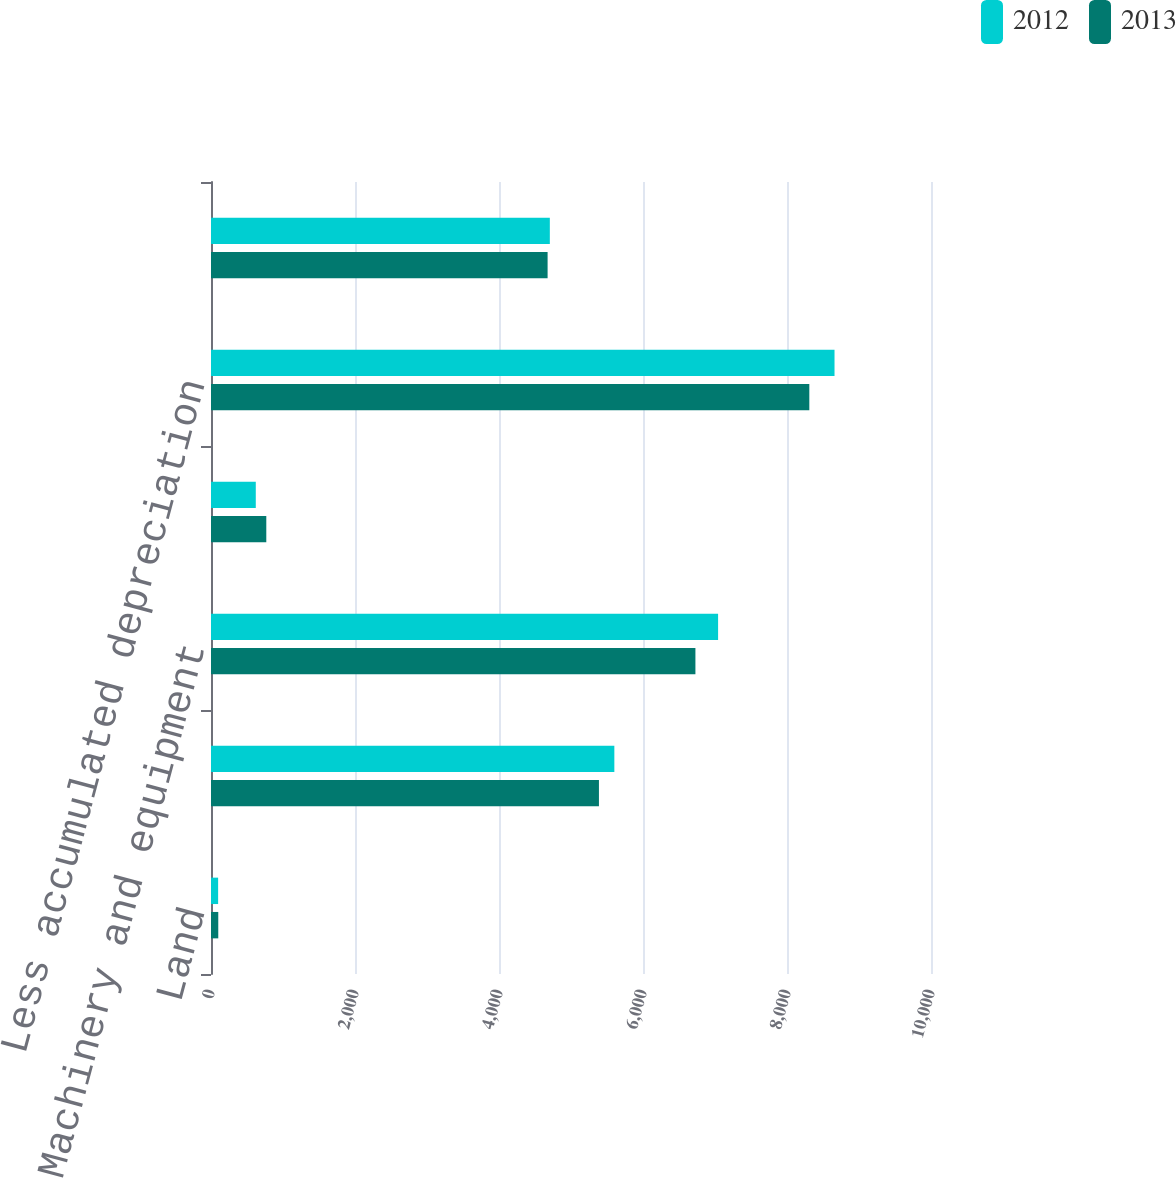<chart> <loc_0><loc_0><loc_500><loc_500><stacked_bar_chart><ecel><fcel>Land<fcel>Buildings<fcel>Machinery and equipment<fcel>Construction in progress<fcel>Less accumulated depreciation<fcel>Total property plant and<nl><fcel>2012<fcel>99<fcel>5602<fcel>7043<fcel>622<fcel>8660<fcel>4706<nl><fcel>2013<fcel>101<fcel>5388<fcel>6728<fcel>768<fcel>8310<fcel>4675<nl></chart> 